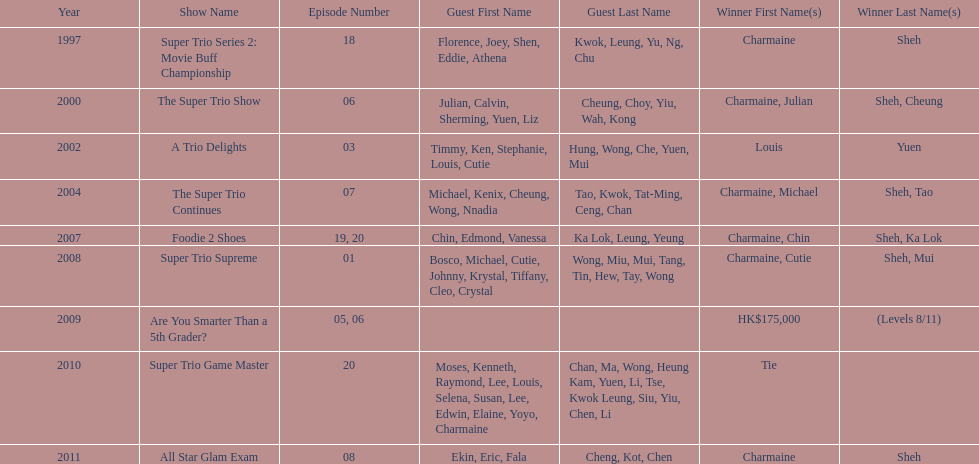What year was the only year were a tie occurred? 2010. 